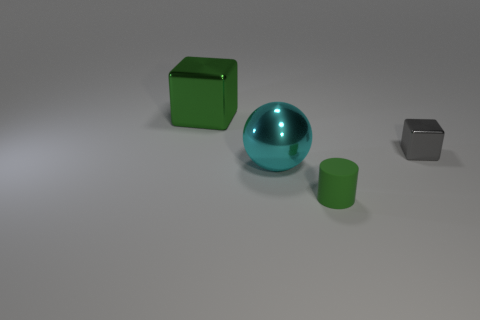There is a big thing that is the same color as the tiny cylinder; what is its shape?
Make the answer very short. Cube. What number of metallic things are either big brown blocks or cyan spheres?
Offer a terse response. 1. There is a green rubber object that is in front of the gray metal block; how many tiny things are on the right side of it?
Provide a short and direct response. 1. The metal object that is the same color as the cylinder is what size?
Make the answer very short. Large. What number of objects are either cubes or shiny objects on the right side of the tiny cylinder?
Ensure brevity in your answer.  2. Is there a green object made of the same material as the big ball?
Keep it short and to the point. Yes. How many things are both to the right of the big ball and left of the small metallic block?
Your answer should be compact. 1. There is a green object that is on the right side of the large cyan ball; what is it made of?
Your response must be concise. Rubber. The other block that is made of the same material as the small block is what size?
Your answer should be very brief. Large. There is a small metallic object; are there any green cylinders right of it?
Provide a succinct answer. No. 